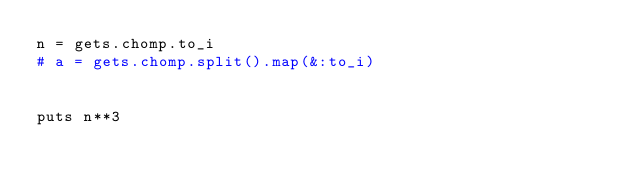Convert code to text. <code><loc_0><loc_0><loc_500><loc_500><_Ruby_>n = gets.chomp.to_i
# a = gets.chomp.split().map(&:to_i)


puts n**3
</code> 